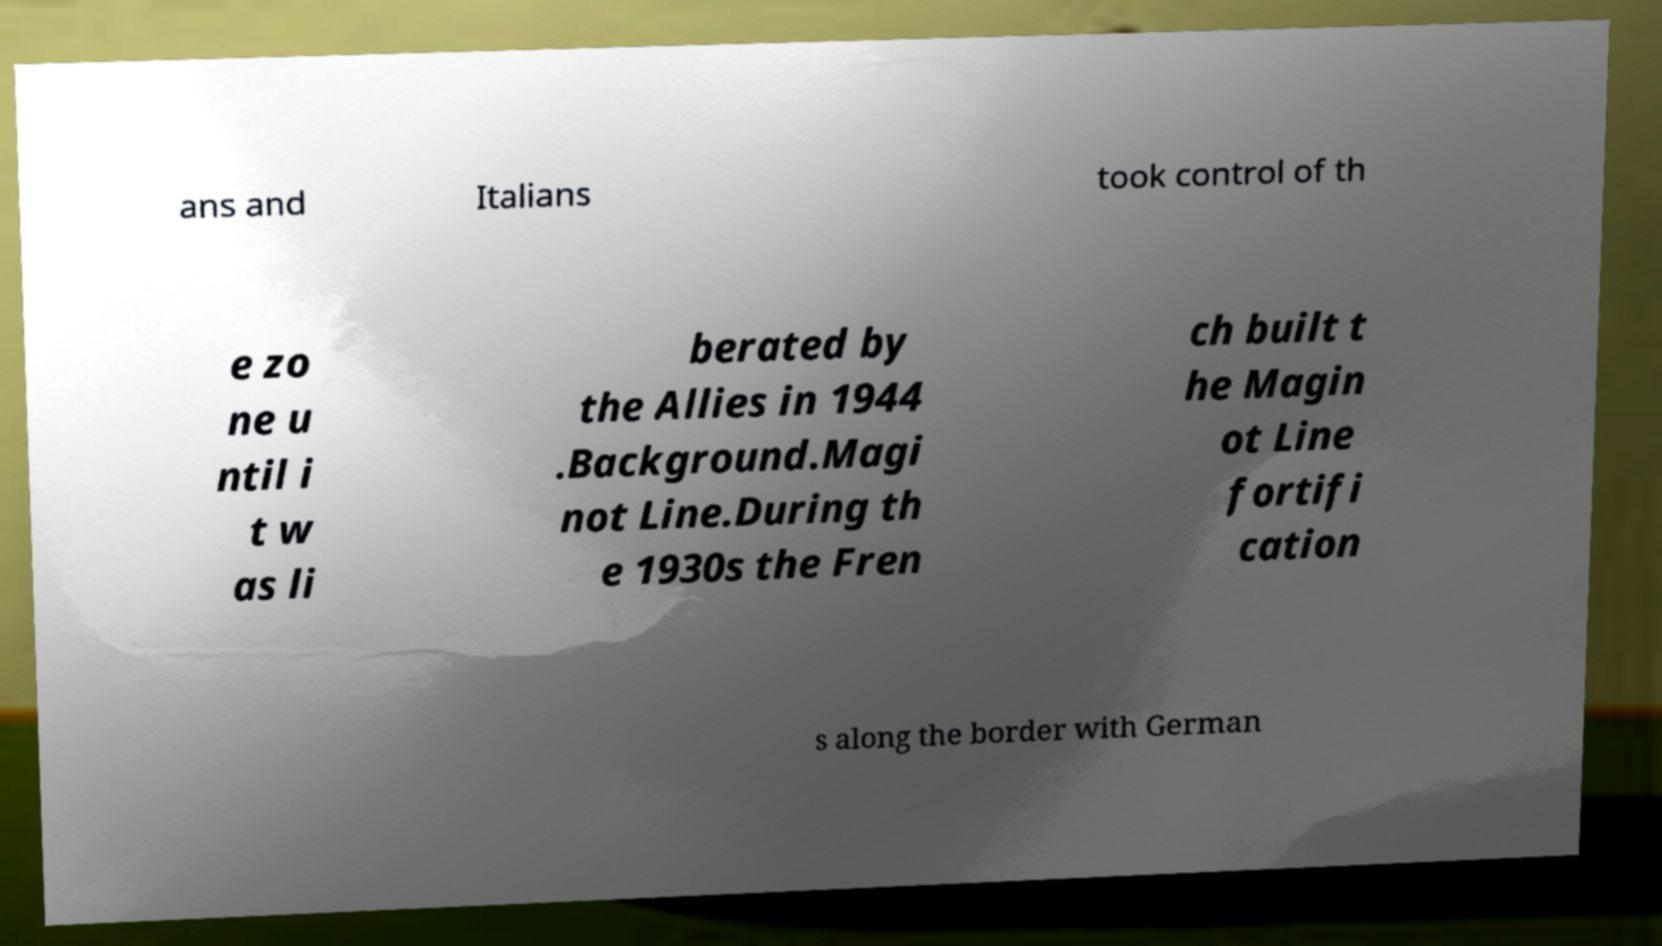Please identify and transcribe the text found in this image. ans and Italians took control of th e zo ne u ntil i t w as li berated by the Allies in 1944 .Background.Magi not Line.During th e 1930s the Fren ch built t he Magin ot Line fortifi cation s along the border with German 